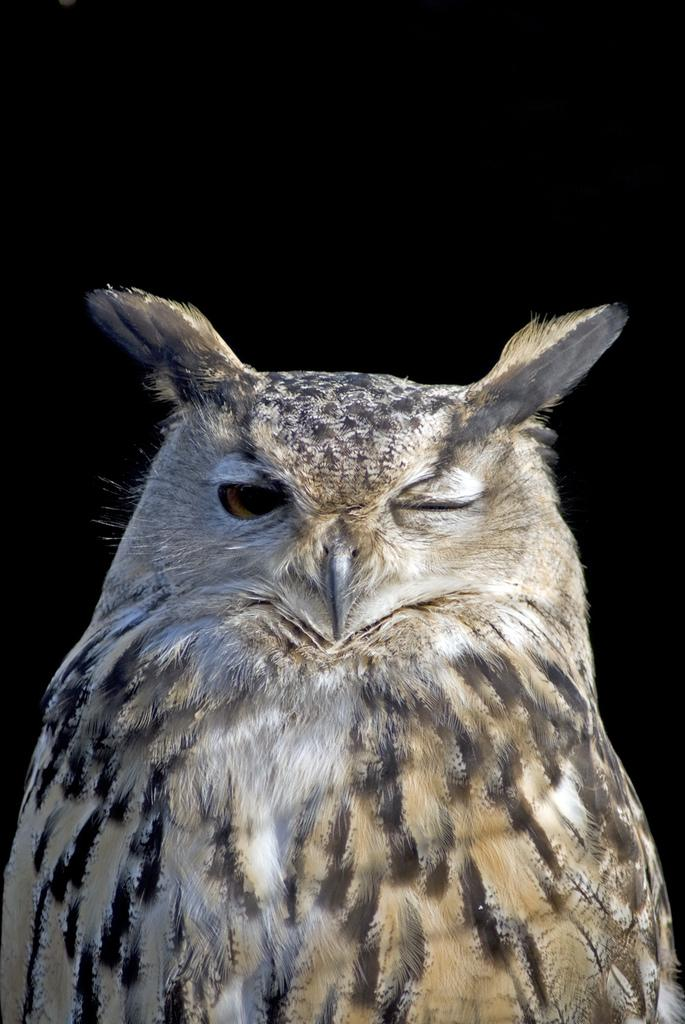What animal is present in the image? There is an owl in the image. What can be observed about the background of the image? The background of the image is dark. What type of account does the owl have in the image? There is no reference to an account in the image, as it features an owl and a dark background. 